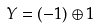Convert formula to latex. <formula><loc_0><loc_0><loc_500><loc_500>Y = ( - { 1 } ) \oplus { 1 }</formula> 